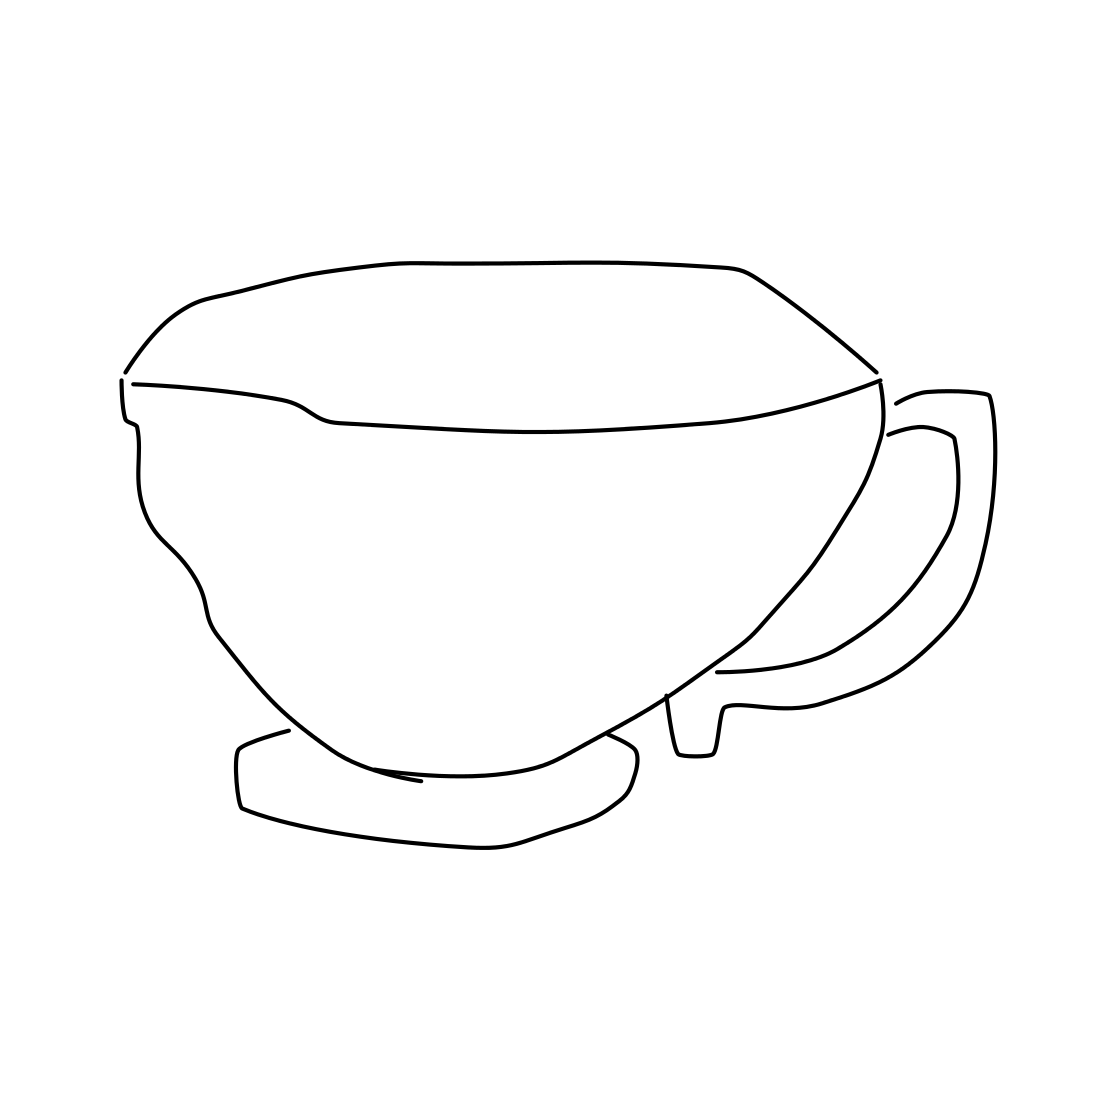If this cup were part of a larger set, what other items might it include? A complete set might include a matching teapot with similar sleek lines, along with a sugar bowl, creamer, and an assortment of plates and bowls, all maintaining the minimalist design theme. 